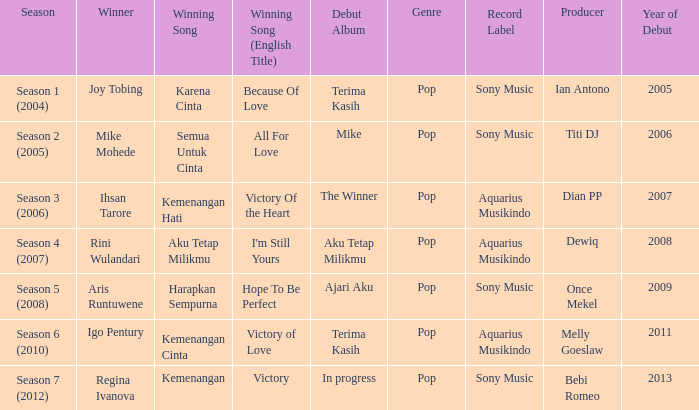Who won with the song kemenangan cinta? Igo Pentury. 